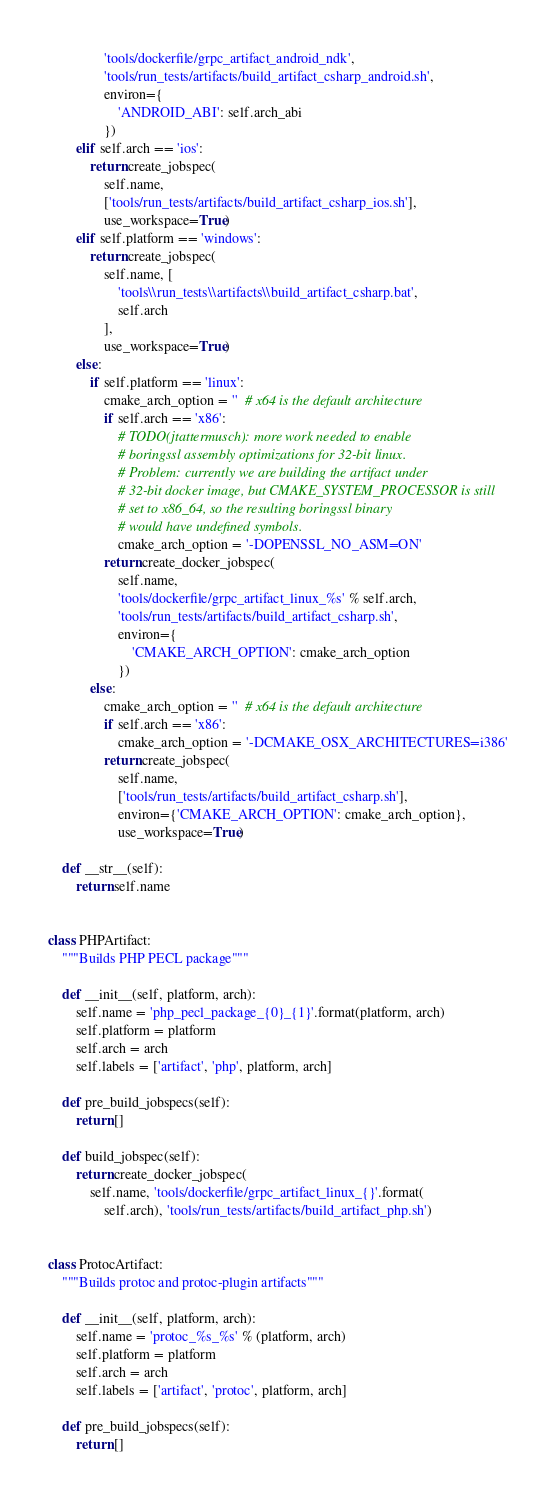<code> <loc_0><loc_0><loc_500><loc_500><_Python_>                'tools/dockerfile/grpc_artifact_android_ndk',
                'tools/run_tests/artifacts/build_artifact_csharp_android.sh',
                environ={
                    'ANDROID_ABI': self.arch_abi
                })
        elif self.arch == 'ios':
            return create_jobspec(
                self.name,
                ['tools/run_tests/artifacts/build_artifact_csharp_ios.sh'],
                use_workspace=True)
        elif self.platform == 'windows':
            return create_jobspec(
                self.name, [
                    'tools\\run_tests\\artifacts\\build_artifact_csharp.bat',
                    self.arch
                ],
                use_workspace=True)
        else:
            if self.platform == 'linux':
                cmake_arch_option = ''  # x64 is the default architecture
                if self.arch == 'x86':
                    # TODO(jtattermusch): more work needed to enable
                    # boringssl assembly optimizations for 32-bit linux.
                    # Problem: currently we are building the artifact under
                    # 32-bit docker image, but CMAKE_SYSTEM_PROCESSOR is still
                    # set to x86_64, so the resulting boringssl binary
                    # would have undefined symbols.
                    cmake_arch_option = '-DOPENSSL_NO_ASM=ON'
                return create_docker_jobspec(
                    self.name,
                    'tools/dockerfile/grpc_artifact_linux_%s' % self.arch,
                    'tools/run_tests/artifacts/build_artifact_csharp.sh',
                    environ={
                        'CMAKE_ARCH_OPTION': cmake_arch_option
                    })
            else:
                cmake_arch_option = ''  # x64 is the default architecture
                if self.arch == 'x86':
                    cmake_arch_option = '-DCMAKE_OSX_ARCHITECTURES=i386'
                return create_jobspec(
                    self.name,
                    ['tools/run_tests/artifacts/build_artifact_csharp.sh'],
                    environ={'CMAKE_ARCH_OPTION': cmake_arch_option},
                    use_workspace=True)

    def __str__(self):
        return self.name


class PHPArtifact:
    """Builds PHP PECL package"""

    def __init__(self, platform, arch):
        self.name = 'php_pecl_package_{0}_{1}'.format(platform, arch)
        self.platform = platform
        self.arch = arch
        self.labels = ['artifact', 'php', platform, arch]

    def pre_build_jobspecs(self):
        return []

    def build_jobspec(self):
        return create_docker_jobspec(
            self.name, 'tools/dockerfile/grpc_artifact_linux_{}'.format(
                self.arch), 'tools/run_tests/artifacts/build_artifact_php.sh')


class ProtocArtifact:
    """Builds protoc and protoc-plugin artifacts"""

    def __init__(self, platform, arch):
        self.name = 'protoc_%s_%s' % (platform, arch)
        self.platform = platform
        self.arch = arch
        self.labels = ['artifact', 'protoc', platform, arch]

    def pre_build_jobspecs(self):
        return []
</code> 